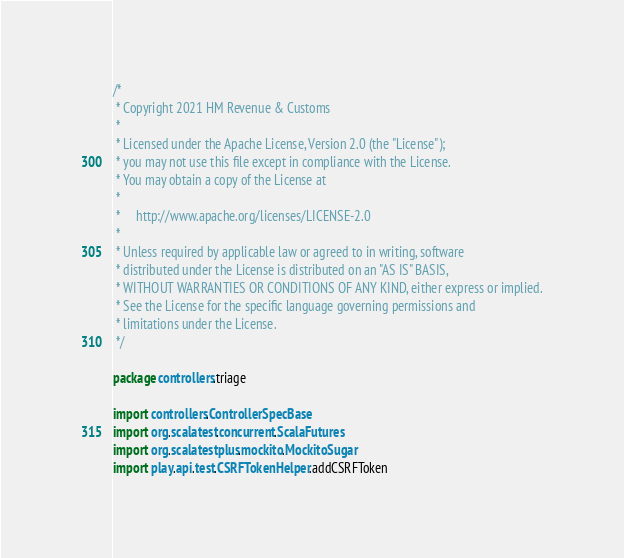<code> <loc_0><loc_0><loc_500><loc_500><_Scala_>/*
 * Copyright 2021 HM Revenue & Customs
 *
 * Licensed under the Apache License, Version 2.0 (the "License");
 * you may not use this file except in compliance with the License.
 * You may obtain a copy of the License at
 *
 *     http://www.apache.org/licenses/LICENSE-2.0
 *
 * Unless required by applicable law or agreed to in writing, software
 * distributed under the License is distributed on an "AS IS" BASIS,
 * WITHOUT WARRANTIES OR CONDITIONS OF ANY KIND, either express or implied.
 * See the License for the specific language governing permissions and
 * limitations under the License.
 */

package controllers.triage

import controllers.ControllerSpecBase
import org.scalatest.concurrent.ScalaFutures
import org.scalatestplus.mockito.MockitoSugar
import play.api.test.CSRFTokenHelper.addCSRFToken</code> 